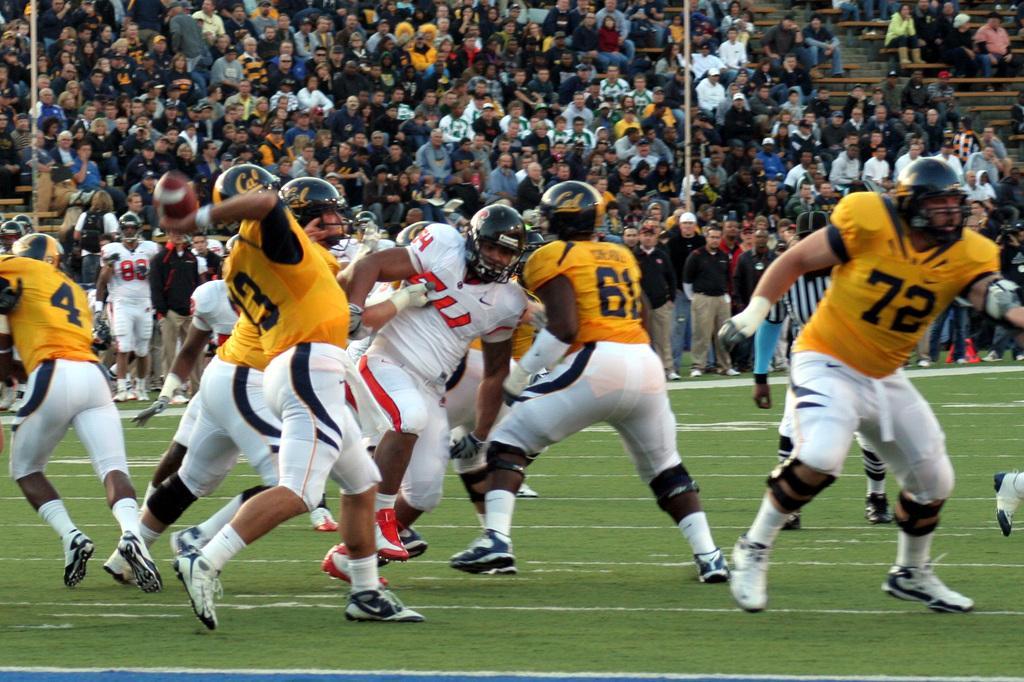How would you summarize this image in a sentence or two? In this image I can see group of people playing game, they are wearing yellow and white color dress. The person in front wearing white and red color dress and black color helmet. Background I can see few other persons sitting and I can see two poles. 